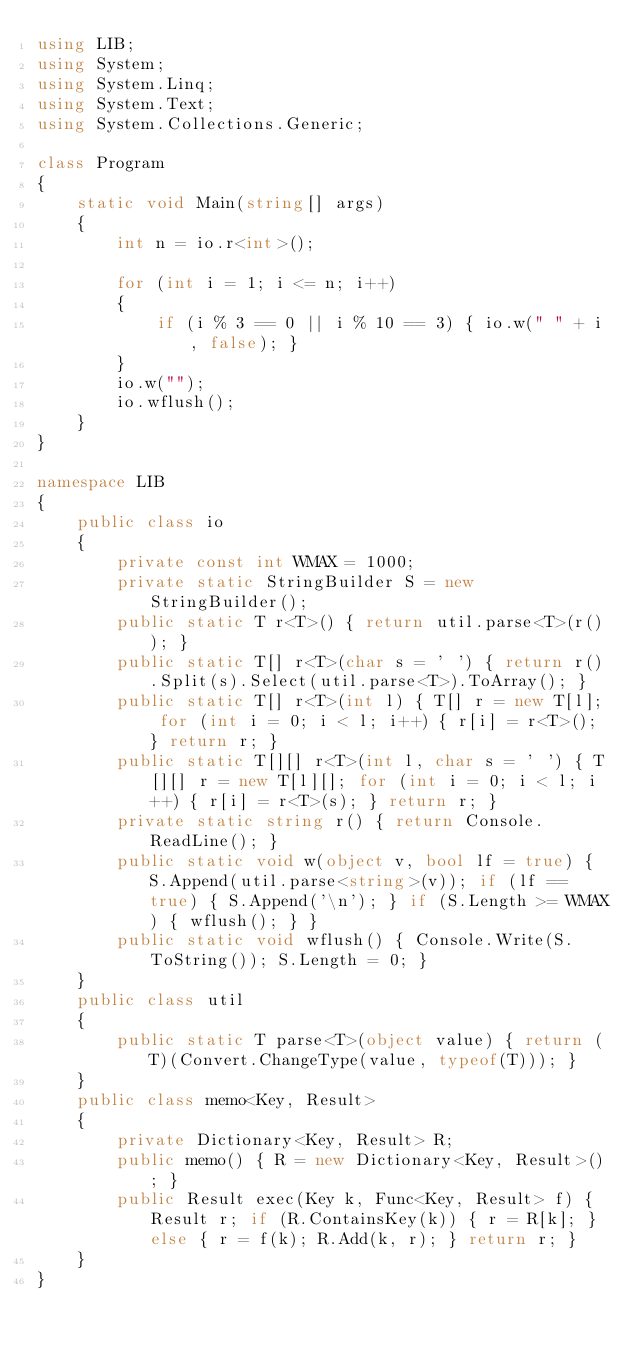<code> <loc_0><loc_0><loc_500><loc_500><_C#_>using LIB;
using System;
using System.Linq;
using System.Text;
using System.Collections.Generic;

class Program
{
    static void Main(string[] args)
    {
        int n = io.r<int>();

        for (int i = 1; i <= n; i++)
        {
            if (i % 3 == 0 || i % 10 == 3) { io.w(" " + i, false); }
        }
        io.w("");
        io.wflush();
    }
}

namespace LIB
{
    public class io
    {
        private const int WMAX = 1000;
        private static StringBuilder S = new StringBuilder();
        public static T r<T>() { return util.parse<T>(r()); }
        public static T[] r<T>(char s = ' ') { return r().Split(s).Select(util.parse<T>).ToArray(); }
        public static T[] r<T>(int l) { T[] r = new T[l]; for (int i = 0; i < l; i++) { r[i] = r<T>(); } return r; }
        public static T[][] r<T>(int l, char s = ' ') { T[][] r = new T[l][]; for (int i = 0; i < l; i++) { r[i] = r<T>(s); } return r; }
        private static string r() { return Console.ReadLine(); }
        public static void w(object v, bool lf = true) { S.Append(util.parse<string>(v)); if (lf == true) { S.Append('\n'); } if (S.Length >= WMAX) { wflush(); } }
        public static void wflush() { Console.Write(S.ToString()); S.Length = 0; }
    }
    public class util
    {
        public static T parse<T>(object value) { return (T)(Convert.ChangeType(value, typeof(T))); }
    }
    public class memo<Key, Result>
    {
        private Dictionary<Key, Result> R;
        public memo() { R = new Dictionary<Key, Result>(); }
        public Result exec(Key k, Func<Key, Result> f) { Result r; if (R.ContainsKey(k)) { r = R[k]; } else { r = f(k); R.Add(k, r); } return r; }
    }
}</code> 